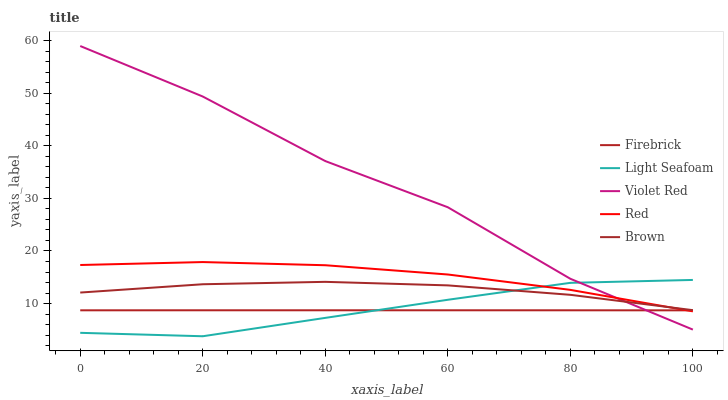Does Firebrick have the minimum area under the curve?
Answer yes or no. Yes. Does Violet Red have the maximum area under the curve?
Answer yes or no. Yes. Does Light Seafoam have the minimum area under the curve?
Answer yes or no. No. Does Light Seafoam have the maximum area under the curve?
Answer yes or no. No. Is Firebrick the smoothest?
Answer yes or no. Yes. Is Violet Red the roughest?
Answer yes or no. Yes. Is Light Seafoam the smoothest?
Answer yes or no. No. Is Light Seafoam the roughest?
Answer yes or no. No. Does Light Seafoam have the lowest value?
Answer yes or no. Yes. Does Firebrick have the lowest value?
Answer yes or no. No. Does Violet Red have the highest value?
Answer yes or no. Yes. Does Light Seafoam have the highest value?
Answer yes or no. No. Is Firebrick less than Brown?
Answer yes or no. Yes. Is Brown greater than Firebrick?
Answer yes or no. Yes. Does Violet Red intersect Red?
Answer yes or no. Yes. Is Violet Red less than Red?
Answer yes or no. No. Is Violet Red greater than Red?
Answer yes or no. No. Does Firebrick intersect Brown?
Answer yes or no. No. 